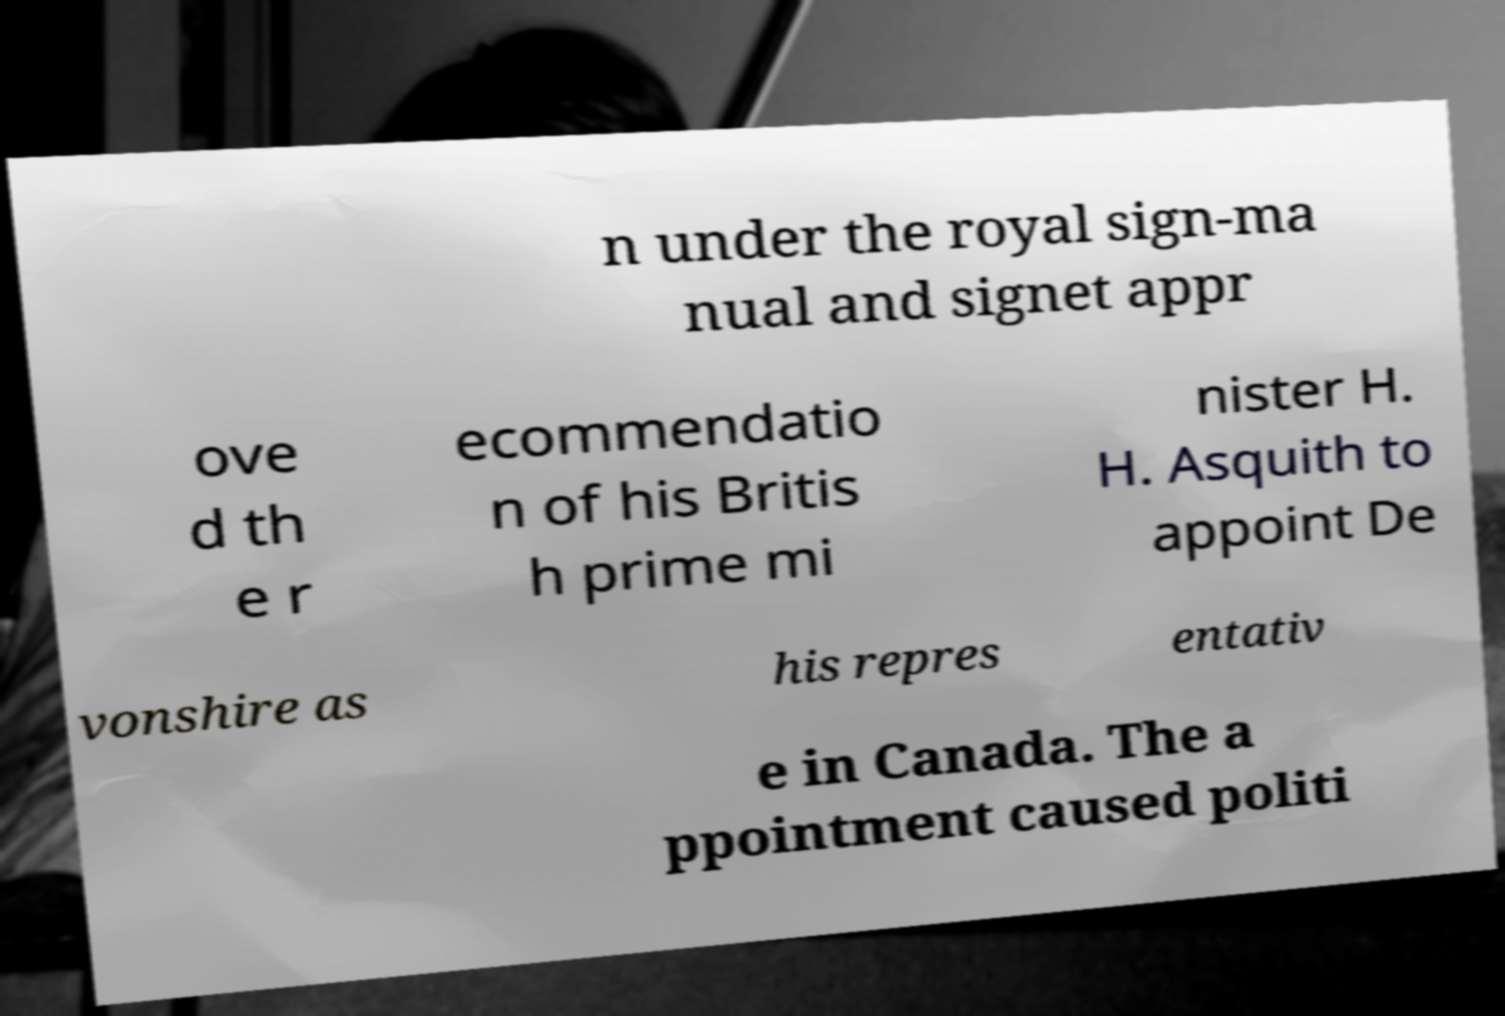I need the written content from this picture converted into text. Can you do that? n under the royal sign-ma nual and signet appr ove d th e r ecommendatio n of his Britis h prime mi nister H. H. Asquith to appoint De vonshire as his repres entativ e in Canada. The a ppointment caused politi 